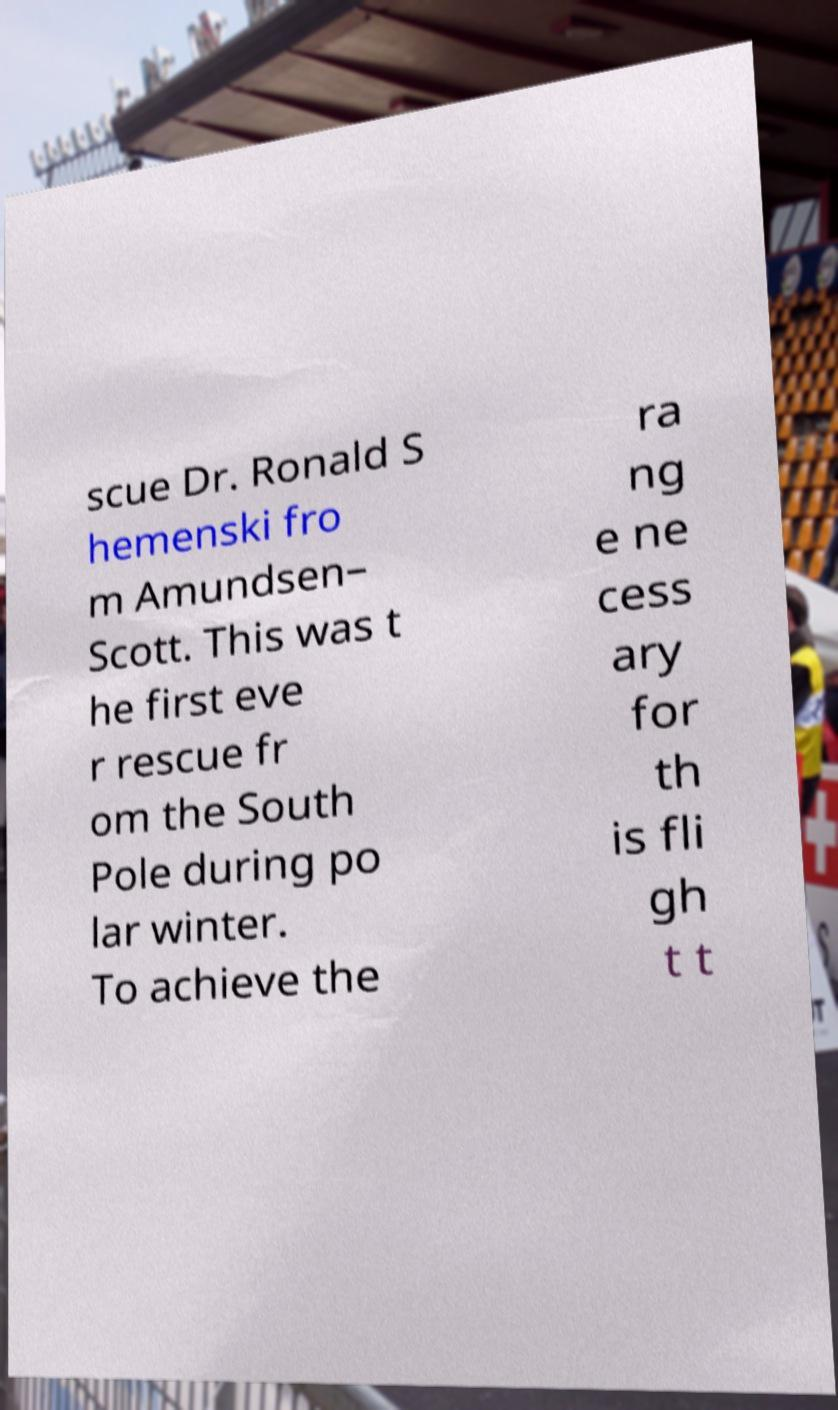Could you assist in decoding the text presented in this image and type it out clearly? scue Dr. Ronald S hemenski fro m Amundsen– Scott. This was t he first eve r rescue fr om the South Pole during po lar winter. To achieve the ra ng e ne cess ary for th is fli gh t t 